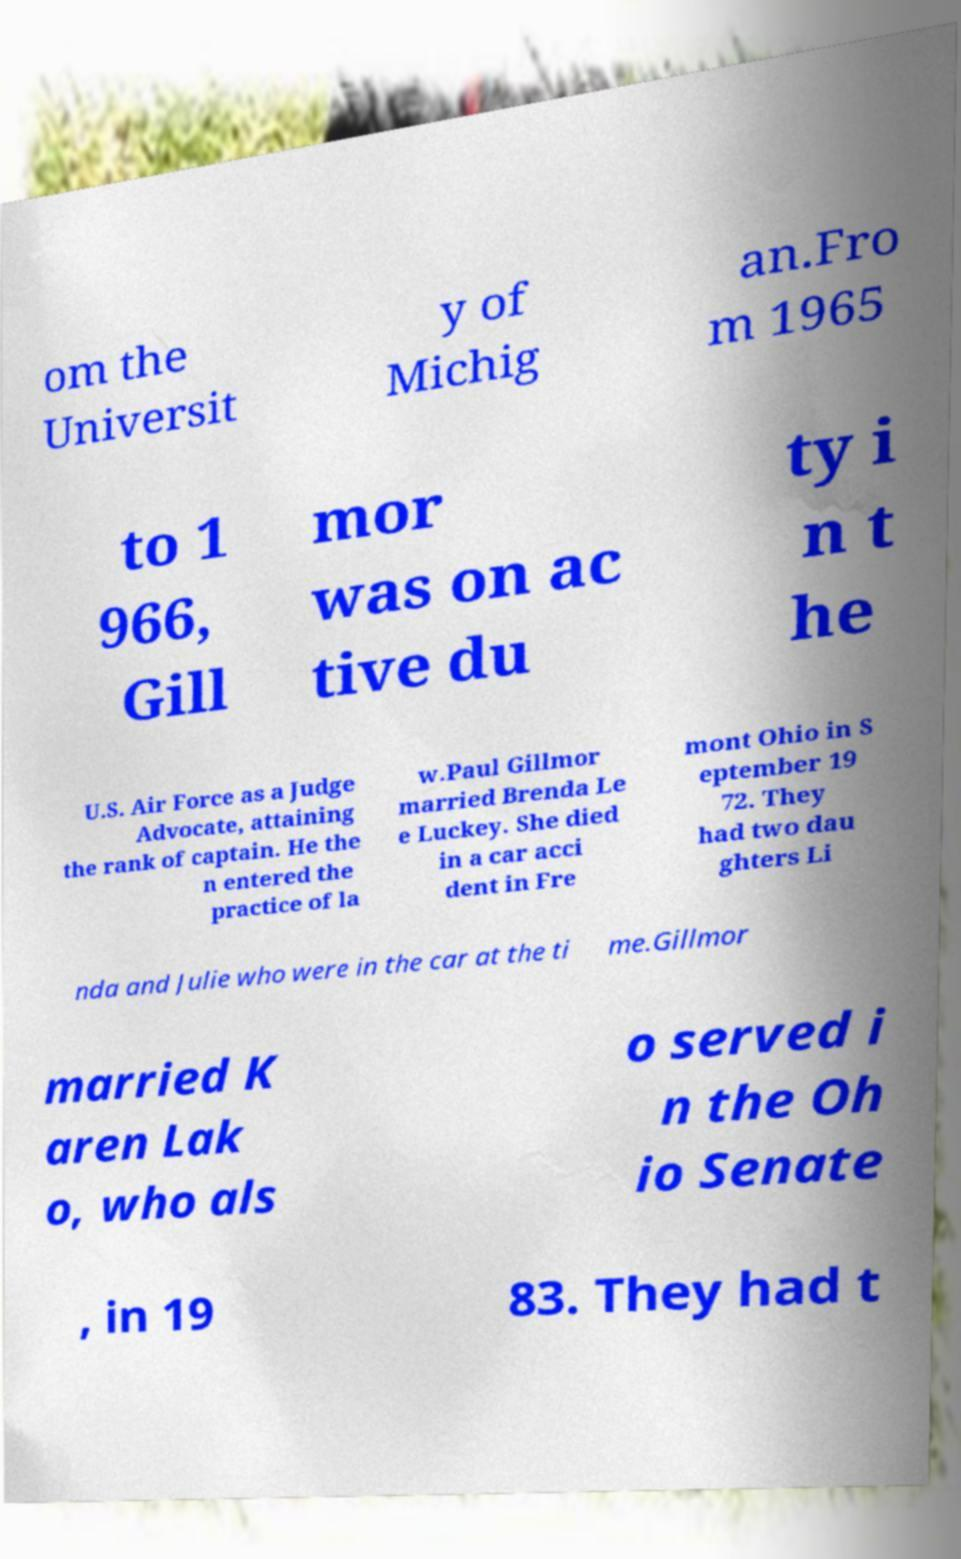Could you assist in decoding the text presented in this image and type it out clearly? om the Universit y of Michig an.Fro m 1965 to 1 966, Gill mor was on ac tive du ty i n t he U.S. Air Force as a Judge Advocate, attaining the rank of captain. He the n entered the practice of la w.Paul Gillmor married Brenda Le e Luckey. She died in a car acci dent in Fre mont Ohio in S eptember 19 72. They had two dau ghters Li nda and Julie who were in the car at the ti me.Gillmor married K aren Lak o, who als o served i n the Oh io Senate , in 19 83. They had t 